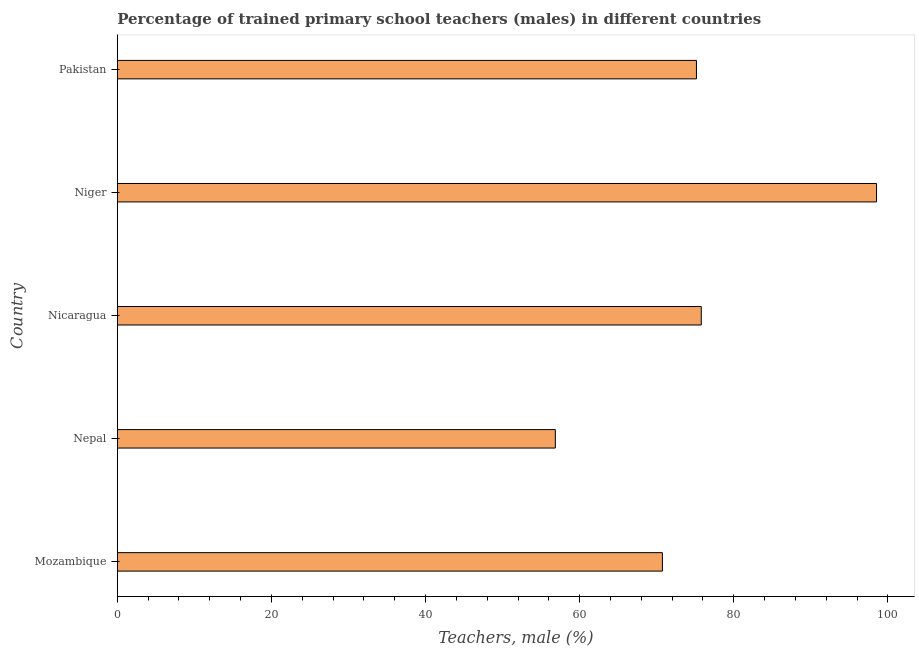Does the graph contain any zero values?
Provide a succinct answer. No. What is the title of the graph?
Your answer should be compact. Percentage of trained primary school teachers (males) in different countries. What is the label or title of the X-axis?
Make the answer very short. Teachers, male (%). What is the label or title of the Y-axis?
Provide a succinct answer. Country. What is the percentage of trained male teachers in Niger?
Your answer should be very brief. 98.53. Across all countries, what is the maximum percentage of trained male teachers?
Offer a terse response. 98.53. Across all countries, what is the minimum percentage of trained male teachers?
Keep it short and to the point. 56.85. In which country was the percentage of trained male teachers maximum?
Ensure brevity in your answer.  Niger. In which country was the percentage of trained male teachers minimum?
Ensure brevity in your answer.  Nepal. What is the sum of the percentage of trained male teachers?
Provide a short and direct response. 377.05. What is the difference between the percentage of trained male teachers in Nepal and Nicaragua?
Provide a succinct answer. -18.94. What is the average percentage of trained male teachers per country?
Give a very brief answer. 75.41. What is the median percentage of trained male teachers?
Provide a short and direct response. 75.16. In how many countries, is the percentage of trained male teachers greater than 8 %?
Provide a succinct answer. 5. What is the ratio of the percentage of trained male teachers in Mozambique to that in Niger?
Offer a very short reply. 0.72. Is the difference between the percentage of trained male teachers in Nepal and Pakistan greater than the difference between any two countries?
Your response must be concise. No. What is the difference between the highest and the second highest percentage of trained male teachers?
Your answer should be compact. 22.74. What is the difference between the highest and the lowest percentage of trained male teachers?
Offer a very short reply. 41.68. What is the Teachers, male (%) in Mozambique?
Provide a succinct answer. 70.74. What is the Teachers, male (%) of Nepal?
Offer a very short reply. 56.85. What is the Teachers, male (%) of Nicaragua?
Make the answer very short. 75.78. What is the Teachers, male (%) in Niger?
Provide a short and direct response. 98.53. What is the Teachers, male (%) of Pakistan?
Your answer should be compact. 75.16. What is the difference between the Teachers, male (%) in Mozambique and Nepal?
Your response must be concise. 13.89. What is the difference between the Teachers, male (%) in Mozambique and Nicaragua?
Offer a very short reply. -5.04. What is the difference between the Teachers, male (%) in Mozambique and Niger?
Ensure brevity in your answer.  -27.79. What is the difference between the Teachers, male (%) in Mozambique and Pakistan?
Make the answer very short. -4.42. What is the difference between the Teachers, male (%) in Nepal and Nicaragua?
Provide a short and direct response. -18.94. What is the difference between the Teachers, male (%) in Nepal and Niger?
Your answer should be compact. -41.68. What is the difference between the Teachers, male (%) in Nepal and Pakistan?
Make the answer very short. -18.31. What is the difference between the Teachers, male (%) in Nicaragua and Niger?
Your answer should be compact. -22.74. What is the difference between the Teachers, male (%) in Nicaragua and Pakistan?
Your answer should be very brief. 0.62. What is the difference between the Teachers, male (%) in Niger and Pakistan?
Keep it short and to the point. 23.37. What is the ratio of the Teachers, male (%) in Mozambique to that in Nepal?
Ensure brevity in your answer.  1.24. What is the ratio of the Teachers, male (%) in Mozambique to that in Nicaragua?
Keep it short and to the point. 0.93. What is the ratio of the Teachers, male (%) in Mozambique to that in Niger?
Keep it short and to the point. 0.72. What is the ratio of the Teachers, male (%) in Mozambique to that in Pakistan?
Make the answer very short. 0.94. What is the ratio of the Teachers, male (%) in Nepal to that in Nicaragua?
Offer a terse response. 0.75. What is the ratio of the Teachers, male (%) in Nepal to that in Niger?
Your response must be concise. 0.58. What is the ratio of the Teachers, male (%) in Nepal to that in Pakistan?
Ensure brevity in your answer.  0.76. What is the ratio of the Teachers, male (%) in Nicaragua to that in Niger?
Your answer should be very brief. 0.77. What is the ratio of the Teachers, male (%) in Niger to that in Pakistan?
Make the answer very short. 1.31. 